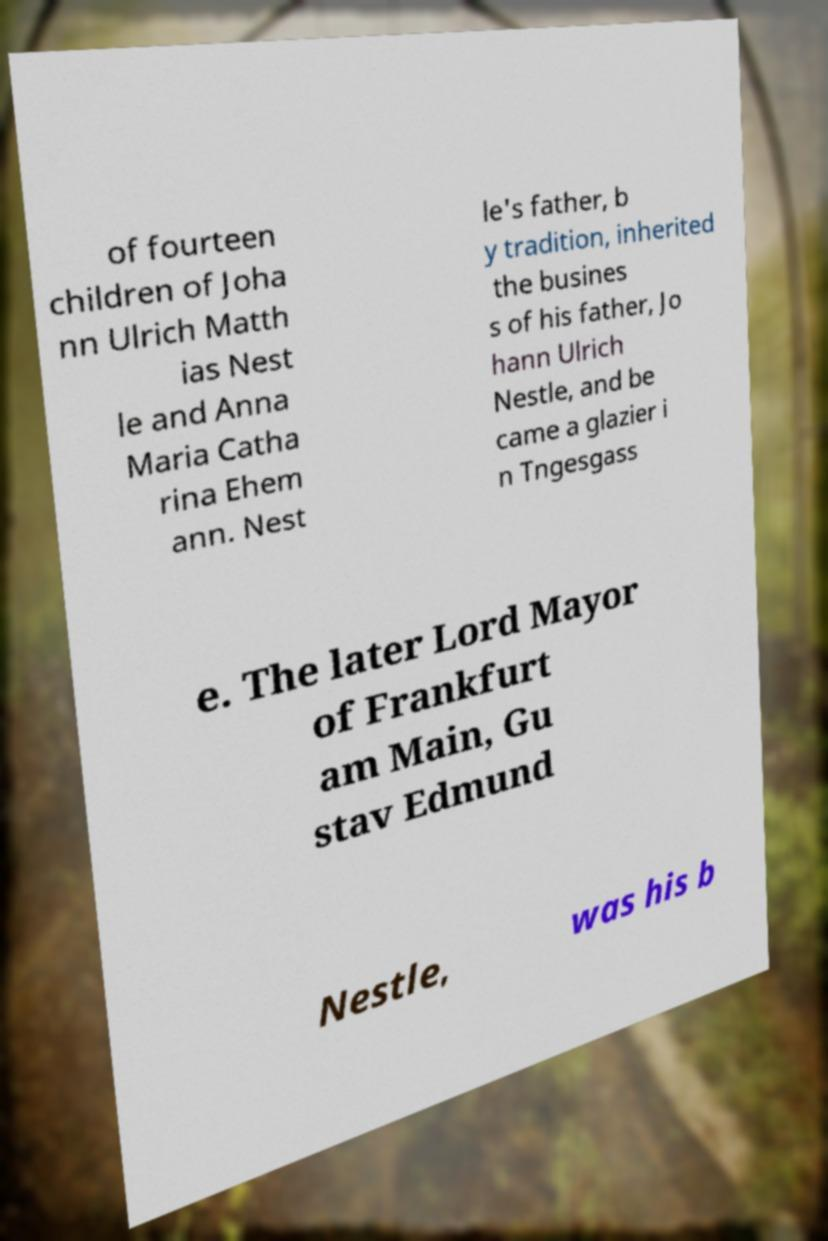I need the written content from this picture converted into text. Can you do that? of fourteen children of Joha nn Ulrich Matth ias Nest le and Anna Maria Catha rina Ehem ann. Nest le's father, b y tradition, inherited the busines s of his father, Jo hann Ulrich Nestle, and be came a glazier i n Tngesgass e. The later Lord Mayor of Frankfurt am Main, Gu stav Edmund Nestle, was his b 